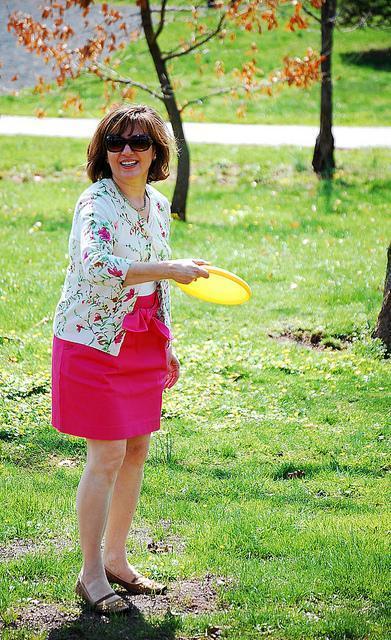How many horses are shown?
Give a very brief answer. 0. 